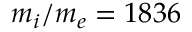Convert formula to latex. <formula><loc_0><loc_0><loc_500><loc_500>m _ { i } / m _ { e } = 1 8 3 6</formula> 